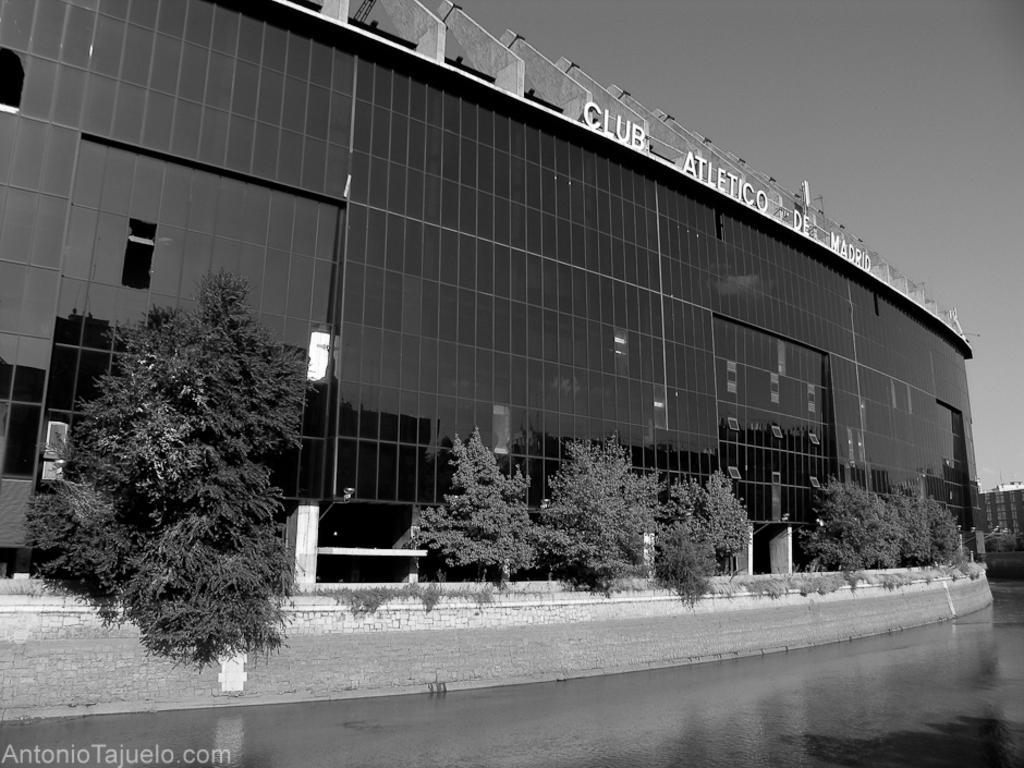Can you describe this image briefly? In this image there is a large building with glasses. There are trees. There is water. There is another building on the right side. 